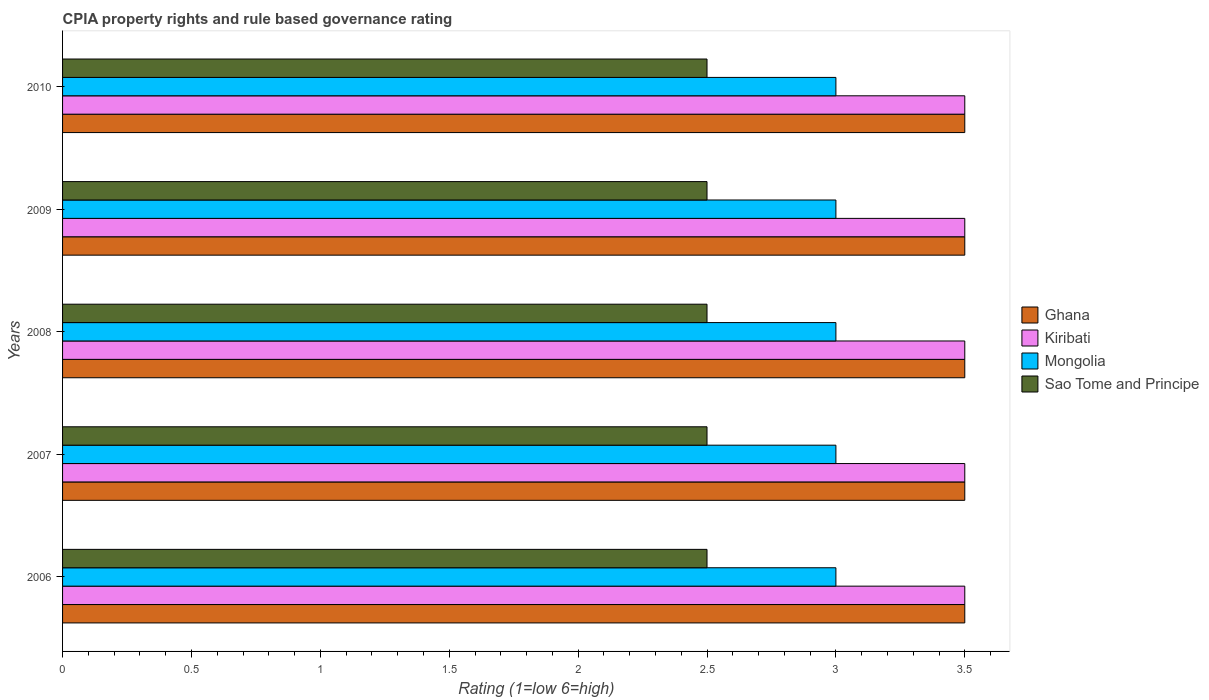How many different coloured bars are there?
Your answer should be very brief. 4. How many groups of bars are there?
Make the answer very short. 5. How many bars are there on the 5th tick from the top?
Your answer should be compact. 4. How many bars are there on the 5th tick from the bottom?
Give a very brief answer. 4. Across all years, what is the minimum CPIA rating in Kiribati?
Ensure brevity in your answer.  3.5. In which year was the CPIA rating in Kiribati maximum?
Make the answer very short. 2006. In which year was the CPIA rating in Kiribati minimum?
Offer a very short reply. 2006. What is the total CPIA rating in Mongolia in the graph?
Your answer should be very brief. 15. What is the difference between the CPIA rating in Kiribati in 2006 and that in 2007?
Make the answer very short. 0. What is the difference between the CPIA rating in Mongolia in 2010 and the CPIA rating in Sao Tome and Principe in 2009?
Offer a very short reply. 0.5. What is the average CPIA rating in Kiribati per year?
Your answer should be very brief. 3.5. In the year 2008, what is the difference between the CPIA rating in Sao Tome and Principe and CPIA rating in Kiribati?
Provide a short and direct response. -1. What is the ratio of the CPIA rating in Sao Tome and Principe in 2006 to that in 2010?
Your response must be concise. 1. Is the CPIA rating in Ghana in 2006 less than that in 2010?
Keep it short and to the point. No. Is the difference between the CPIA rating in Sao Tome and Principe in 2006 and 2007 greater than the difference between the CPIA rating in Kiribati in 2006 and 2007?
Provide a short and direct response. No. What is the difference between the highest and the lowest CPIA rating in Ghana?
Make the answer very short. 0. In how many years, is the CPIA rating in Mongolia greater than the average CPIA rating in Mongolia taken over all years?
Your answer should be very brief. 0. Is it the case that in every year, the sum of the CPIA rating in Ghana and CPIA rating in Sao Tome and Principe is greater than the sum of CPIA rating in Mongolia and CPIA rating in Kiribati?
Your answer should be compact. No. What does the 4th bar from the top in 2006 represents?
Offer a very short reply. Ghana. What does the 4th bar from the bottom in 2008 represents?
Ensure brevity in your answer.  Sao Tome and Principe. Is it the case that in every year, the sum of the CPIA rating in Sao Tome and Principe and CPIA rating in Ghana is greater than the CPIA rating in Kiribati?
Your answer should be compact. Yes. Does the graph contain any zero values?
Provide a short and direct response. No. How many legend labels are there?
Make the answer very short. 4. How are the legend labels stacked?
Your answer should be compact. Vertical. What is the title of the graph?
Your response must be concise. CPIA property rights and rule based governance rating. Does "Vietnam" appear as one of the legend labels in the graph?
Keep it short and to the point. No. What is the Rating (1=low 6=high) of Kiribati in 2006?
Your answer should be compact. 3.5. What is the Rating (1=low 6=high) in Ghana in 2007?
Make the answer very short. 3.5. What is the Rating (1=low 6=high) of Kiribati in 2007?
Make the answer very short. 3.5. What is the Rating (1=low 6=high) of Ghana in 2008?
Give a very brief answer. 3.5. What is the Rating (1=low 6=high) of Mongolia in 2008?
Provide a short and direct response. 3. What is the Rating (1=low 6=high) in Ghana in 2010?
Provide a succinct answer. 3.5. What is the Rating (1=low 6=high) of Kiribati in 2010?
Your response must be concise. 3.5. What is the Rating (1=low 6=high) in Mongolia in 2010?
Keep it short and to the point. 3. What is the Rating (1=low 6=high) of Sao Tome and Principe in 2010?
Offer a very short reply. 2.5. Across all years, what is the maximum Rating (1=low 6=high) of Ghana?
Ensure brevity in your answer.  3.5. Across all years, what is the maximum Rating (1=low 6=high) in Kiribati?
Your response must be concise. 3.5. Across all years, what is the maximum Rating (1=low 6=high) of Sao Tome and Principe?
Provide a succinct answer. 2.5. Across all years, what is the minimum Rating (1=low 6=high) in Ghana?
Keep it short and to the point. 3.5. Across all years, what is the minimum Rating (1=low 6=high) of Kiribati?
Give a very brief answer. 3.5. Across all years, what is the minimum Rating (1=low 6=high) of Sao Tome and Principe?
Your response must be concise. 2.5. What is the total Rating (1=low 6=high) of Ghana in the graph?
Make the answer very short. 17.5. What is the total Rating (1=low 6=high) in Kiribati in the graph?
Provide a short and direct response. 17.5. What is the total Rating (1=low 6=high) in Mongolia in the graph?
Your response must be concise. 15. What is the total Rating (1=low 6=high) in Sao Tome and Principe in the graph?
Provide a succinct answer. 12.5. What is the difference between the Rating (1=low 6=high) of Ghana in 2006 and that in 2007?
Offer a very short reply. 0. What is the difference between the Rating (1=low 6=high) in Mongolia in 2006 and that in 2007?
Ensure brevity in your answer.  0. What is the difference between the Rating (1=low 6=high) of Sao Tome and Principe in 2006 and that in 2007?
Your answer should be compact. 0. What is the difference between the Rating (1=low 6=high) of Ghana in 2006 and that in 2008?
Offer a very short reply. 0. What is the difference between the Rating (1=low 6=high) in Mongolia in 2006 and that in 2008?
Provide a succinct answer. 0. What is the difference between the Rating (1=low 6=high) of Ghana in 2006 and that in 2009?
Keep it short and to the point. 0. What is the difference between the Rating (1=low 6=high) in Kiribati in 2006 and that in 2009?
Make the answer very short. 0. What is the difference between the Rating (1=low 6=high) of Mongolia in 2006 and that in 2009?
Provide a succinct answer. 0. What is the difference between the Rating (1=low 6=high) of Ghana in 2006 and that in 2010?
Ensure brevity in your answer.  0. What is the difference between the Rating (1=low 6=high) in Kiribati in 2006 and that in 2010?
Your answer should be very brief. 0. What is the difference between the Rating (1=low 6=high) of Ghana in 2007 and that in 2009?
Your response must be concise. 0. What is the difference between the Rating (1=low 6=high) in Kiribati in 2007 and that in 2009?
Your answer should be compact. 0. What is the difference between the Rating (1=low 6=high) in Mongolia in 2007 and that in 2009?
Make the answer very short. 0. What is the difference between the Rating (1=low 6=high) in Ghana in 2007 and that in 2010?
Make the answer very short. 0. What is the difference between the Rating (1=low 6=high) of Kiribati in 2007 and that in 2010?
Ensure brevity in your answer.  0. What is the difference between the Rating (1=low 6=high) of Sao Tome and Principe in 2007 and that in 2010?
Your response must be concise. 0. What is the difference between the Rating (1=low 6=high) in Ghana in 2008 and that in 2009?
Provide a succinct answer. 0. What is the difference between the Rating (1=low 6=high) in Kiribati in 2008 and that in 2009?
Keep it short and to the point. 0. What is the difference between the Rating (1=low 6=high) of Mongolia in 2008 and that in 2009?
Your answer should be compact. 0. What is the difference between the Rating (1=low 6=high) in Kiribati in 2008 and that in 2010?
Provide a short and direct response. 0. What is the difference between the Rating (1=low 6=high) in Sao Tome and Principe in 2008 and that in 2010?
Your answer should be compact. 0. What is the difference between the Rating (1=low 6=high) in Sao Tome and Principe in 2009 and that in 2010?
Provide a short and direct response. 0. What is the difference between the Rating (1=low 6=high) of Ghana in 2006 and the Rating (1=low 6=high) of Kiribati in 2007?
Offer a terse response. 0. What is the difference between the Rating (1=low 6=high) in Kiribati in 2006 and the Rating (1=low 6=high) in Mongolia in 2007?
Offer a very short reply. 0.5. What is the difference between the Rating (1=low 6=high) of Kiribati in 2006 and the Rating (1=low 6=high) of Sao Tome and Principe in 2007?
Your answer should be compact. 1. What is the difference between the Rating (1=low 6=high) of Mongolia in 2006 and the Rating (1=low 6=high) of Sao Tome and Principe in 2007?
Keep it short and to the point. 0.5. What is the difference between the Rating (1=low 6=high) in Kiribati in 2006 and the Rating (1=low 6=high) in Sao Tome and Principe in 2008?
Your answer should be very brief. 1. What is the difference between the Rating (1=low 6=high) of Ghana in 2006 and the Rating (1=low 6=high) of Kiribati in 2009?
Ensure brevity in your answer.  0. What is the difference between the Rating (1=low 6=high) in Ghana in 2006 and the Rating (1=low 6=high) in Sao Tome and Principe in 2009?
Your answer should be very brief. 1. What is the difference between the Rating (1=low 6=high) in Kiribati in 2006 and the Rating (1=low 6=high) in Mongolia in 2009?
Offer a terse response. 0.5. What is the difference between the Rating (1=low 6=high) of Kiribati in 2006 and the Rating (1=low 6=high) of Sao Tome and Principe in 2009?
Provide a succinct answer. 1. What is the difference between the Rating (1=low 6=high) of Mongolia in 2006 and the Rating (1=low 6=high) of Sao Tome and Principe in 2009?
Make the answer very short. 0.5. What is the difference between the Rating (1=low 6=high) in Ghana in 2006 and the Rating (1=low 6=high) in Kiribati in 2010?
Give a very brief answer. 0. What is the difference between the Rating (1=low 6=high) of Ghana in 2006 and the Rating (1=low 6=high) of Sao Tome and Principe in 2010?
Your answer should be compact. 1. What is the difference between the Rating (1=low 6=high) of Kiribati in 2006 and the Rating (1=low 6=high) of Sao Tome and Principe in 2010?
Offer a very short reply. 1. What is the difference between the Rating (1=low 6=high) of Ghana in 2007 and the Rating (1=low 6=high) of Mongolia in 2008?
Make the answer very short. 0.5. What is the difference between the Rating (1=low 6=high) of Ghana in 2007 and the Rating (1=low 6=high) of Sao Tome and Principe in 2008?
Offer a very short reply. 1. What is the difference between the Rating (1=low 6=high) in Mongolia in 2007 and the Rating (1=low 6=high) in Sao Tome and Principe in 2008?
Offer a terse response. 0.5. What is the difference between the Rating (1=low 6=high) in Ghana in 2007 and the Rating (1=low 6=high) in Kiribati in 2009?
Make the answer very short. 0. What is the difference between the Rating (1=low 6=high) of Ghana in 2007 and the Rating (1=low 6=high) of Sao Tome and Principe in 2009?
Make the answer very short. 1. What is the difference between the Rating (1=low 6=high) in Kiribati in 2007 and the Rating (1=low 6=high) in Sao Tome and Principe in 2009?
Your response must be concise. 1. What is the difference between the Rating (1=low 6=high) of Mongolia in 2007 and the Rating (1=low 6=high) of Sao Tome and Principe in 2009?
Provide a short and direct response. 0.5. What is the difference between the Rating (1=low 6=high) of Ghana in 2007 and the Rating (1=low 6=high) of Mongolia in 2010?
Your response must be concise. 0.5. What is the difference between the Rating (1=low 6=high) in Ghana in 2007 and the Rating (1=low 6=high) in Sao Tome and Principe in 2010?
Give a very brief answer. 1. What is the difference between the Rating (1=low 6=high) in Kiribati in 2007 and the Rating (1=low 6=high) in Mongolia in 2010?
Make the answer very short. 0.5. What is the difference between the Rating (1=low 6=high) of Kiribati in 2007 and the Rating (1=low 6=high) of Sao Tome and Principe in 2010?
Offer a very short reply. 1. What is the difference between the Rating (1=low 6=high) of Ghana in 2008 and the Rating (1=low 6=high) of Kiribati in 2009?
Your response must be concise. 0. What is the difference between the Rating (1=low 6=high) in Ghana in 2008 and the Rating (1=low 6=high) in Sao Tome and Principe in 2009?
Give a very brief answer. 1. What is the difference between the Rating (1=low 6=high) in Kiribati in 2008 and the Rating (1=low 6=high) in Mongolia in 2009?
Provide a succinct answer. 0.5. What is the difference between the Rating (1=low 6=high) of Kiribati in 2008 and the Rating (1=low 6=high) of Sao Tome and Principe in 2009?
Provide a short and direct response. 1. What is the difference between the Rating (1=low 6=high) of Ghana in 2008 and the Rating (1=low 6=high) of Kiribati in 2010?
Provide a succinct answer. 0. What is the difference between the Rating (1=low 6=high) of Ghana in 2008 and the Rating (1=low 6=high) of Mongolia in 2010?
Your answer should be very brief. 0.5. What is the difference between the Rating (1=low 6=high) of Kiribati in 2008 and the Rating (1=low 6=high) of Mongolia in 2010?
Offer a terse response. 0.5. What is the difference between the Rating (1=low 6=high) of Kiribati in 2008 and the Rating (1=low 6=high) of Sao Tome and Principe in 2010?
Your answer should be very brief. 1. What is the difference between the Rating (1=low 6=high) of Mongolia in 2008 and the Rating (1=low 6=high) of Sao Tome and Principe in 2010?
Offer a terse response. 0.5. What is the difference between the Rating (1=low 6=high) in Ghana in 2009 and the Rating (1=low 6=high) in Kiribati in 2010?
Give a very brief answer. 0. What is the difference between the Rating (1=low 6=high) in Ghana in 2009 and the Rating (1=low 6=high) in Sao Tome and Principe in 2010?
Your answer should be very brief. 1. What is the difference between the Rating (1=low 6=high) of Kiribati in 2009 and the Rating (1=low 6=high) of Sao Tome and Principe in 2010?
Make the answer very short. 1. What is the difference between the Rating (1=low 6=high) in Mongolia in 2009 and the Rating (1=low 6=high) in Sao Tome and Principe in 2010?
Your answer should be very brief. 0.5. What is the average Rating (1=low 6=high) of Ghana per year?
Provide a succinct answer. 3.5. What is the average Rating (1=low 6=high) of Mongolia per year?
Your answer should be very brief. 3. In the year 2006, what is the difference between the Rating (1=low 6=high) in Ghana and Rating (1=low 6=high) in Kiribati?
Provide a succinct answer. 0. In the year 2006, what is the difference between the Rating (1=low 6=high) in Ghana and Rating (1=low 6=high) in Mongolia?
Ensure brevity in your answer.  0.5. In the year 2006, what is the difference between the Rating (1=low 6=high) of Ghana and Rating (1=low 6=high) of Sao Tome and Principe?
Your answer should be compact. 1. In the year 2006, what is the difference between the Rating (1=low 6=high) in Kiribati and Rating (1=low 6=high) in Mongolia?
Make the answer very short. 0.5. In the year 2007, what is the difference between the Rating (1=low 6=high) of Ghana and Rating (1=low 6=high) of Kiribati?
Make the answer very short. 0. In the year 2007, what is the difference between the Rating (1=low 6=high) in Ghana and Rating (1=low 6=high) in Sao Tome and Principe?
Make the answer very short. 1. In the year 2008, what is the difference between the Rating (1=low 6=high) of Ghana and Rating (1=low 6=high) of Kiribati?
Offer a terse response. 0. In the year 2008, what is the difference between the Rating (1=low 6=high) of Ghana and Rating (1=low 6=high) of Mongolia?
Give a very brief answer. 0.5. In the year 2008, what is the difference between the Rating (1=low 6=high) of Ghana and Rating (1=low 6=high) of Sao Tome and Principe?
Give a very brief answer. 1. In the year 2008, what is the difference between the Rating (1=low 6=high) of Kiribati and Rating (1=low 6=high) of Mongolia?
Keep it short and to the point. 0.5. In the year 2009, what is the difference between the Rating (1=low 6=high) of Ghana and Rating (1=low 6=high) of Sao Tome and Principe?
Provide a short and direct response. 1. In the year 2009, what is the difference between the Rating (1=low 6=high) of Kiribati and Rating (1=low 6=high) of Mongolia?
Keep it short and to the point. 0.5. In the year 2009, what is the difference between the Rating (1=low 6=high) in Mongolia and Rating (1=low 6=high) in Sao Tome and Principe?
Ensure brevity in your answer.  0.5. In the year 2010, what is the difference between the Rating (1=low 6=high) in Ghana and Rating (1=low 6=high) in Kiribati?
Provide a succinct answer. 0. In the year 2010, what is the difference between the Rating (1=low 6=high) of Ghana and Rating (1=low 6=high) of Sao Tome and Principe?
Your response must be concise. 1. In the year 2010, what is the difference between the Rating (1=low 6=high) of Kiribati and Rating (1=low 6=high) of Mongolia?
Ensure brevity in your answer.  0.5. In the year 2010, what is the difference between the Rating (1=low 6=high) in Mongolia and Rating (1=low 6=high) in Sao Tome and Principe?
Make the answer very short. 0.5. What is the ratio of the Rating (1=low 6=high) in Ghana in 2006 to that in 2007?
Make the answer very short. 1. What is the ratio of the Rating (1=low 6=high) in Ghana in 2006 to that in 2008?
Give a very brief answer. 1. What is the ratio of the Rating (1=low 6=high) in Ghana in 2006 to that in 2009?
Provide a short and direct response. 1. What is the ratio of the Rating (1=low 6=high) of Kiribati in 2006 to that in 2009?
Provide a short and direct response. 1. What is the ratio of the Rating (1=low 6=high) in Ghana in 2006 to that in 2010?
Give a very brief answer. 1. What is the ratio of the Rating (1=low 6=high) in Mongolia in 2006 to that in 2010?
Offer a terse response. 1. What is the ratio of the Rating (1=low 6=high) of Sao Tome and Principe in 2006 to that in 2010?
Your response must be concise. 1. What is the ratio of the Rating (1=low 6=high) in Ghana in 2007 to that in 2008?
Ensure brevity in your answer.  1. What is the ratio of the Rating (1=low 6=high) of Kiribati in 2007 to that in 2008?
Make the answer very short. 1. What is the ratio of the Rating (1=low 6=high) of Mongolia in 2007 to that in 2008?
Give a very brief answer. 1. What is the ratio of the Rating (1=low 6=high) in Sao Tome and Principe in 2007 to that in 2008?
Make the answer very short. 1. What is the ratio of the Rating (1=low 6=high) in Kiribati in 2007 to that in 2009?
Make the answer very short. 1. What is the ratio of the Rating (1=low 6=high) in Sao Tome and Principe in 2007 to that in 2009?
Provide a short and direct response. 1. What is the ratio of the Rating (1=low 6=high) in Ghana in 2007 to that in 2010?
Ensure brevity in your answer.  1. What is the ratio of the Rating (1=low 6=high) of Ghana in 2008 to that in 2010?
Ensure brevity in your answer.  1. What is the ratio of the Rating (1=low 6=high) of Sao Tome and Principe in 2008 to that in 2010?
Give a very brief answer. 1. What is the ratio of the Rating (1=low 6=high) in Ghana in 2009 to that in 2010?
Provide a succinct answer. 1. What is the ratio of the Rating (1=low 6=high) in Kiribati in 2009 to that in 2010?
Your answer should be compact. 1. What is the ratio of the Rating (1=low 6=high) of Mongolia in 2009 to that in 2010?
Offer a terse response. 1. What is the difference between the highest and the second highest Rating (1=low 6=high) of Kiribati?
Offer a very short reply. 0. What is the difference between the highest and the second highest Rating (1=low 6=high) in Mongolia?
Ensure brevity in your answer.  0. What is the difference between the highest and the lowest Rating (1=low 6=high) of Kiribati?
Give a very brief answer. 0. 